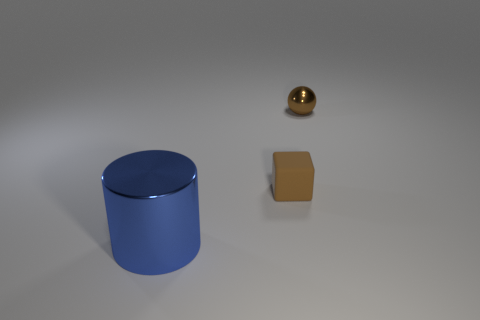There is a object that is the same color as the tiny ball; what size is it?
Your answer should be very brief. Small. How many objects are behind the blue metal object and in front of the tiny metal ball?
Provide a short and direct response. 1. What size is the object that is made of the same material as the brown ball?
Your answer should be very brief. Large. How many other large things are the same shape as the blue metal thing?
Offer a very short reply. 0. Is the number of large blue things on the right side of the small rubber object greater than the number of tiny yellow metallic cylinders?
Keep it short and to the point. No. The thing that is both behind the blue metallic object and in front of the small metal thing has what shape?
Offer a terse response. Cube. Does the metal sphere have the same size as the blue shiny cylinder?
Offer a terse response. No. What number of big metallic cylinders are on the right side of the brown rubber thing?
Your response must be concise. 0. Are there the same number of matte cubes to the left of the brown rubber thing and blue cylinders in front of the big blue cylinder?
Give a very brief answer. Yes. There is a metallic thing that is right of the big blue metallic cylinder; is it the same shape as the large shiny object?
Your answer should be very brief. No. 